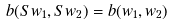Convert formula to latex. <formula><loc_0><loc_0><loc_500><loc_500>b ( S w _ { 1 } , S w _ { 2 } ) = b ( w _ { 1 } , w _ { 2 } )</formula> 